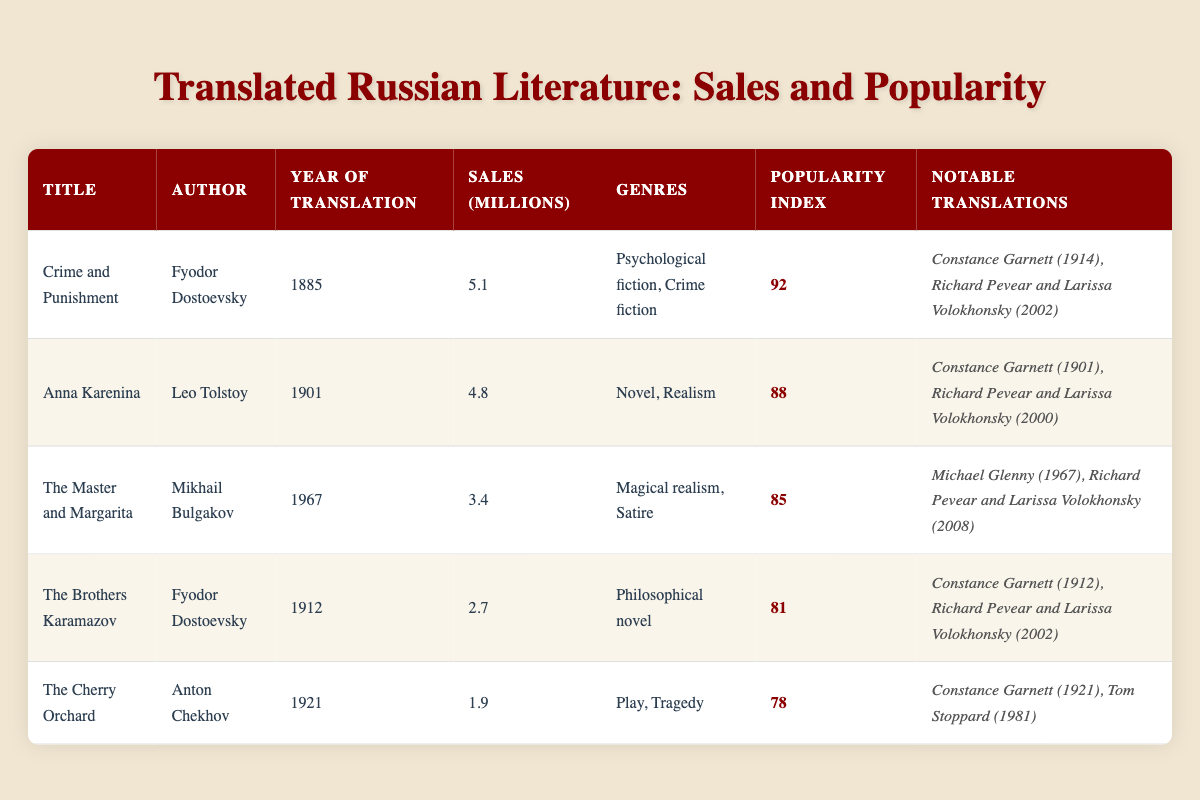What is the highest sales figure for a translated Russian literary work? "Crime and Punishment" has the highest sales figure at 5.1 million. This value can be found in the "Sales (Millions)" column for the title "Crime and Punishment."
Answer: 5.1 Which author has the most translated works listed in this table? Fyodor Dostoevsky appears twice in the table, with "Crime and Punishment" and "The Brothers Karamazov." This means he has the most translated works listed here.
Answer: Fyodor Dostoevsky What is the average global popularity index of the works presented in the table? To find the average, sum the global popularity indexes (92 + 88 + 85 + 81 + 78 = 424) and divide by the number of works (5), which results in an average of 424 / 5 = 84.8.
Answer: 84.8 Was "The Cherry Orchard" translated earlier than "The Master and Margarita"? "The Cherry Orchard" was translated in 1921, while "The Master and Margarita" was translated in 1967. Therefore, "The Cherry Orchard" was translated earlier.
Answer: Yes Which title, authored by Fyodor Dostoevsky, has the lower sales figure: "Crime and Punishment" or "The Brothers Karamazov"? "Crime and Punishment" has sales of 5.1 million, while "The Brothers Karamazov" has sales of 2.7 million. Comparing these figures shows that "The Brothers Karamazov" has the lower sales.
Answer: The Brothers Karamazov How many translations of "Anna Karenina" are notable in the table? There are two notable translations of "Anna Karenina" listed: one by Constance Garnett in 1901 and another by Richard Pevear and Larissa Volokhonsky in 2000. Counting them gives a total of two notable translations.
Answer: 2 What is the difference in sales between "The Master and Margarita" and "The Cherry Orchard"? "The Master and Margarita" has sales of 3.4 million while "The Cherry Orchard" has sales of 1.9 million. The difference is 3.4 million - 1.9 million = 1.5 million.
Answer: 1.5 million Which work had the highest global popularity index, and who was its translator in 1914? "Crime and Punishment" has the highest global popularity index of 92. The notable translator in 1914 was Constance Garnett. Thus, the answer combines both pieces of information.
Answer: Crime and Punishment, Constance Garnett List the genres associated with "The Brothers Karamazov." The genres associated with "The Brothers Karamazov" are indicated in the table as "Philosophical novel." This data point can be directly retrieved from its respective row.
Answer: Philosophical novel Is there a translated work with a popularity index lower than "The Cherry Orchard"? "The Cherry Orchard" has a popularity index of 78. None of the listed works has a lower index; the lowest index is 78. Thus, the answer is no.
Answer: No 